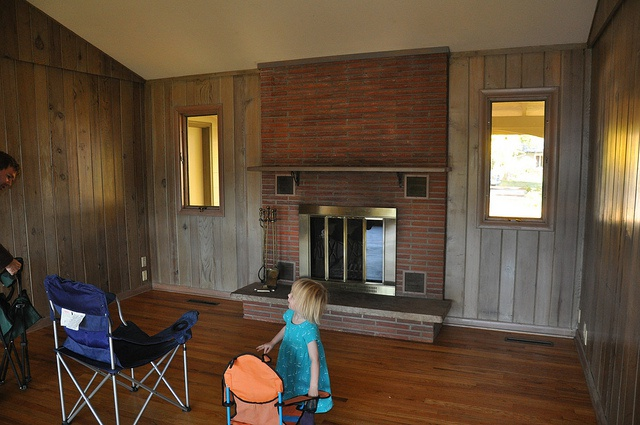Describe the objects in this image and their specific colors. I can see chair in black, maroon, navy, and gray tones, people in black, teal, and darkgray tones, chair in black, salmon, and maroon tones, and people in black, maroon, and gray tones in this image. 